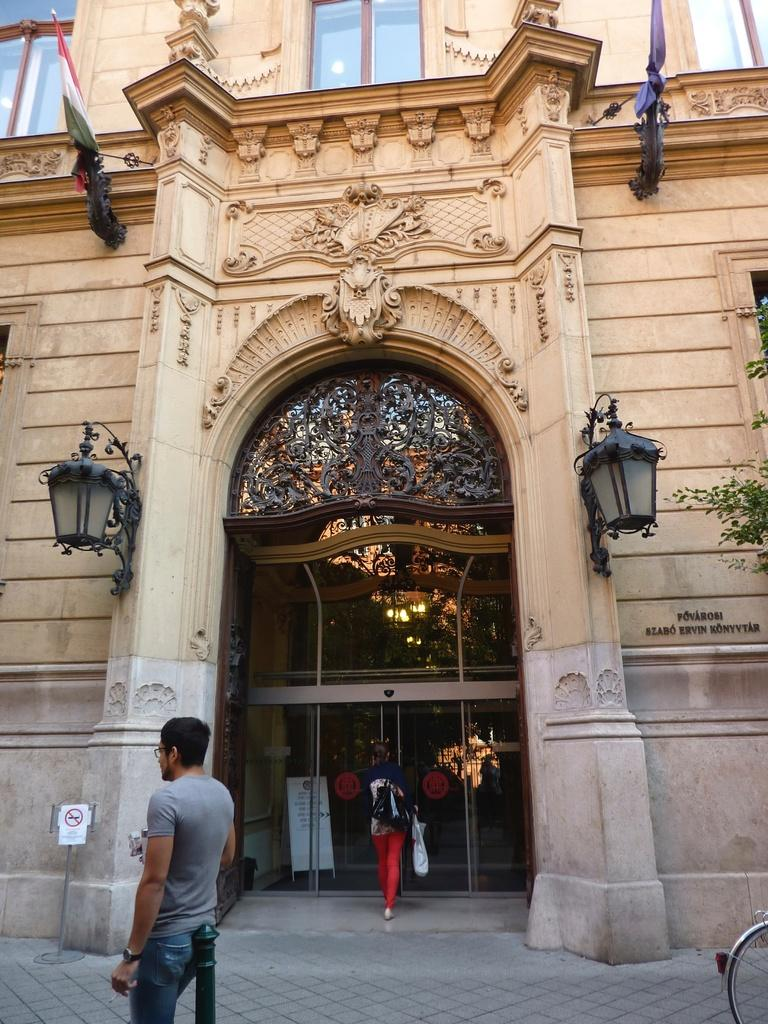What type of structure is present in the image? There is a building in the image. What can be seen near the building? There are lamps and flags near the building. What type of doors are on the building? There are glass doors on the building. What are the two persons in the image doing? The two persons are walking through the footpath. How many legs can be seen on the mine in the image? There is no mine present in the image, so it is not possible to determine the number of legs on a mine. 